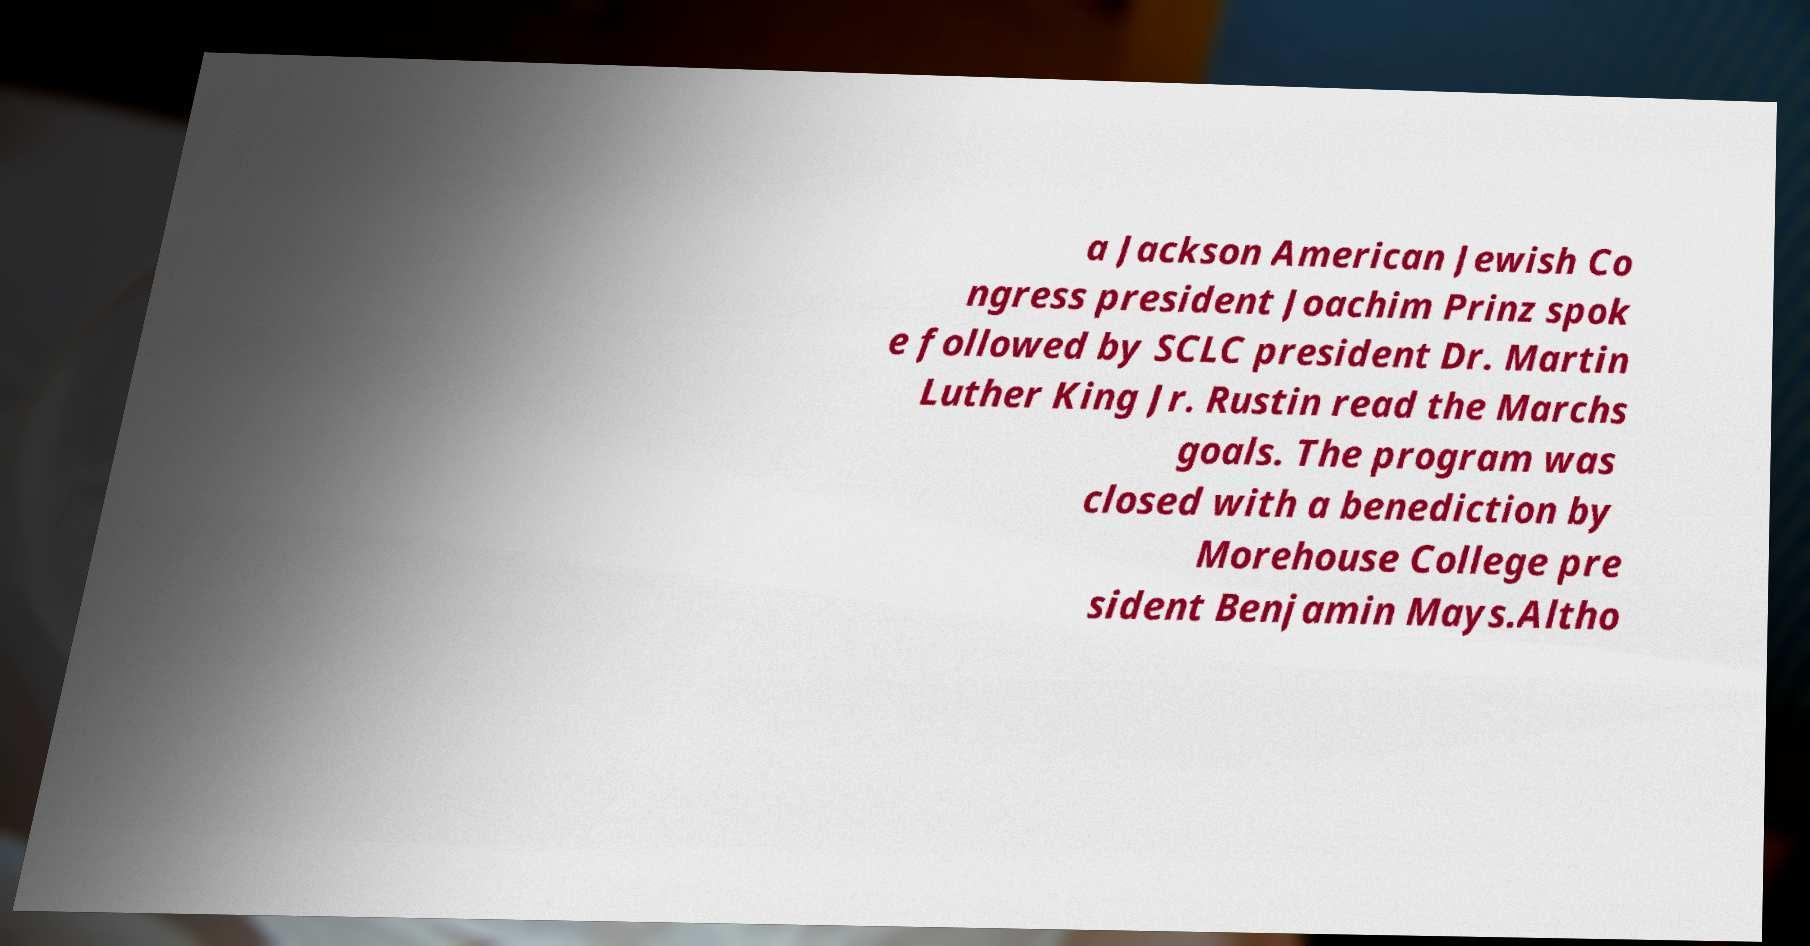There's text embedded in this image that I need extracted. Can you transcribe it verbatim? a Jackson American Jewish Co ngress president Joachim Prinz spok e followed by SCLC president Dr. Martin Luther King Jr. Rustin read the Marchs goals. The program was closed with a benediction by Morehouse College pre sident Benjamin Mays.Altho 